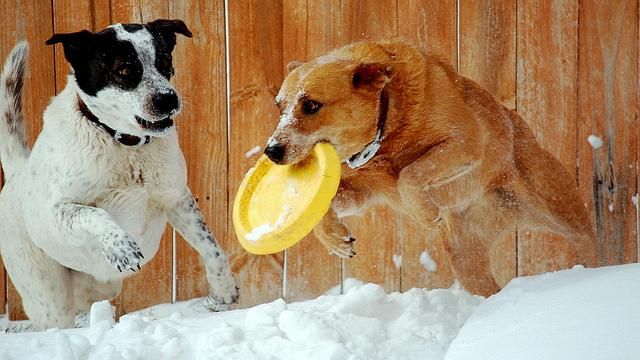What game are they playing? frisbee 